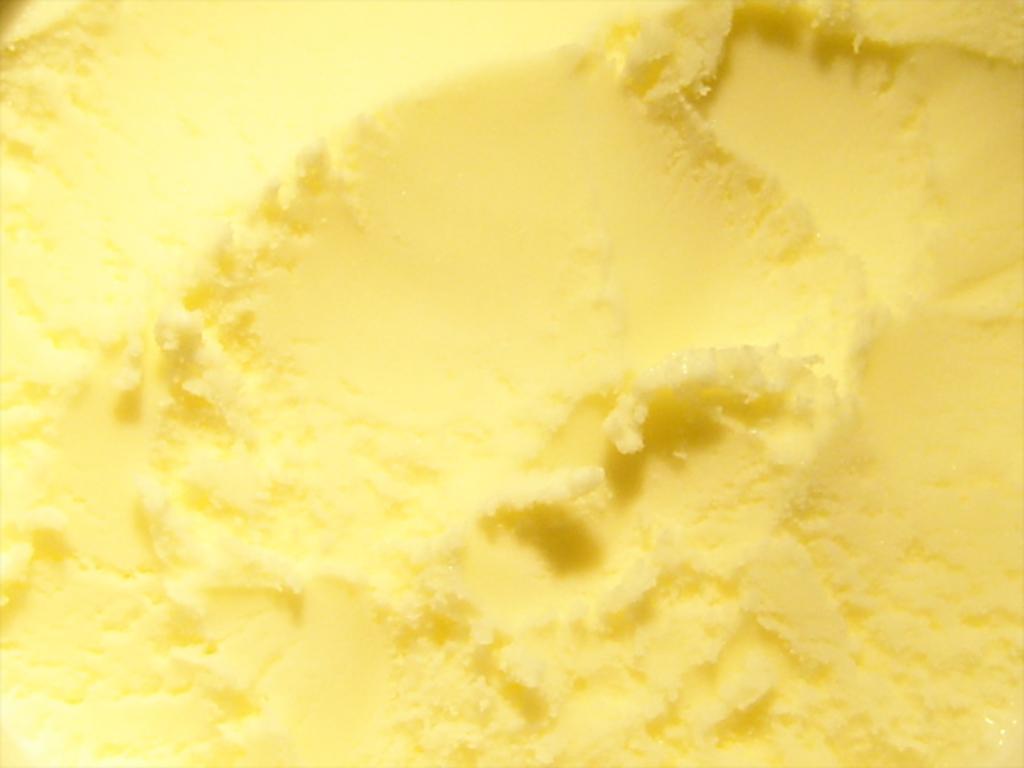Describe this image in one or two sentences. In this picture, it seems like texture in the image. 